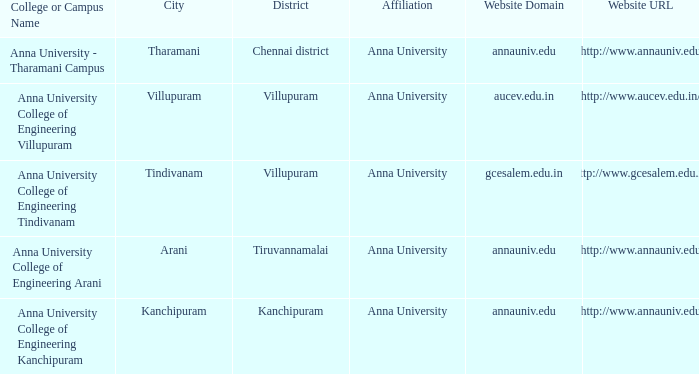What District has a Location of villupuram? Villupuram. 